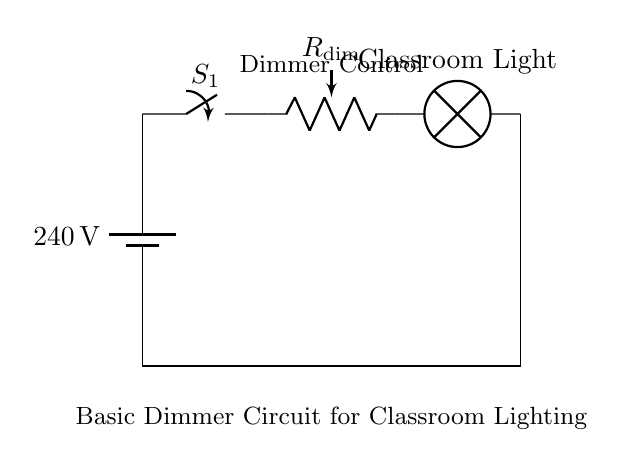What is the voltage of this circuit? The battery is labeled with a potential difference of 240 volts, indicating that this is the voltage supplied to the circuit.
Answer: 240 volts What component is used to control the brightness of the light? The circuit diagram shows a potentiometer labeled as R_dim, which is used to vary resistance and hence adjust the brightness of the lamp.
Answer: R_dim What is the purpose of the switch in this circuit? The switch, labeled S_1, is for turning the circuit on or off; closing the switch allows current to flow, while opening it interrupts the circuit.
Answer: To turn the circuit on/off How many main components are present in the circuit? The circuit consists of four main components: a battery, a switch, a potentiometer, and a lamp.
Answer: Four What happens when the dimmer (potentiometer) is adjusted to a higher resistance? Increasing the resistance of the potentiometer reduces the current flowing to the lamp, thus dimming the light.
Answer: The light dims What type of circuit is illustrated here? This circuit is a basic dimmer circuit specifically designed for classroom lighting control, allowing for adjustable illumination based on needs.
Answer: Basic dimmer circuit 